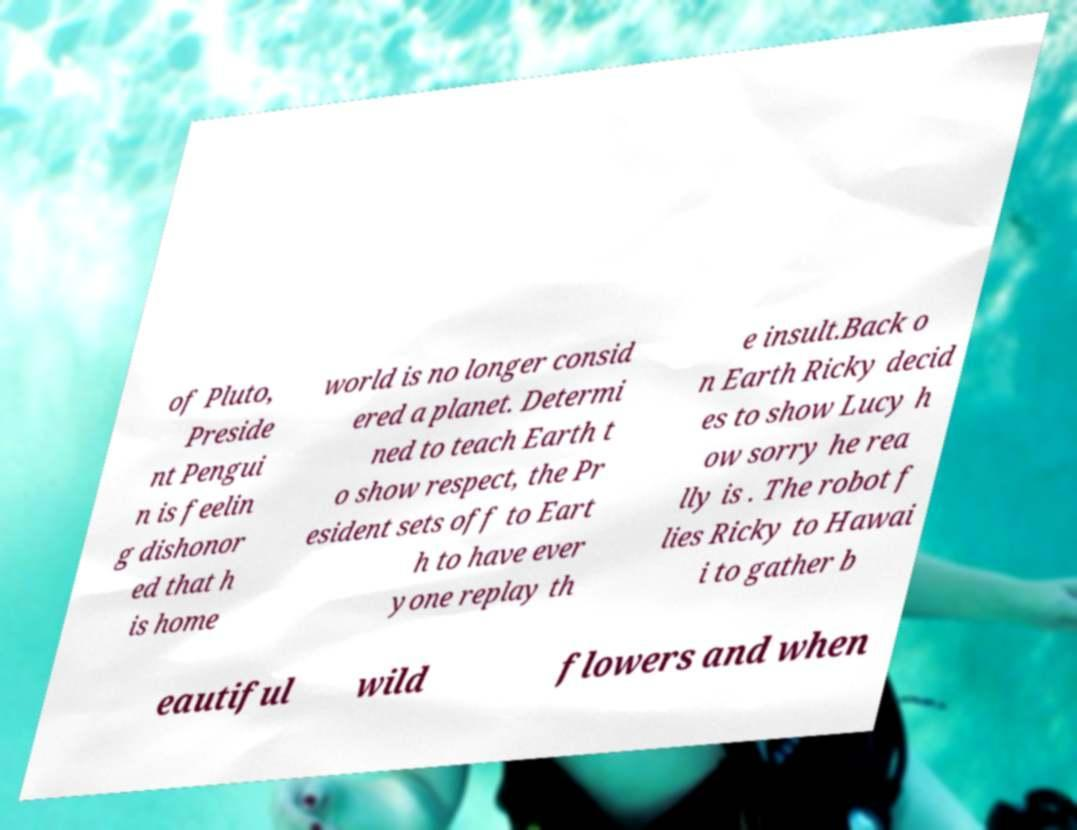I need the written content from this picture converted into text. Can you do that? of Pluto, Preside nt Pengui n is feelin g dishonor ed that h is home world is no longer consid ered a planet. Determi ned to teach Earth t o show respect, the Pr esident sets off to Eart h to have ever yone replay th e insult.Back o n Earth Ricky decid es to show Lucy h ow sorry he rea lly is . The robot f lies Ricky to Hawai i to gather b eautiful wild flowers and when 